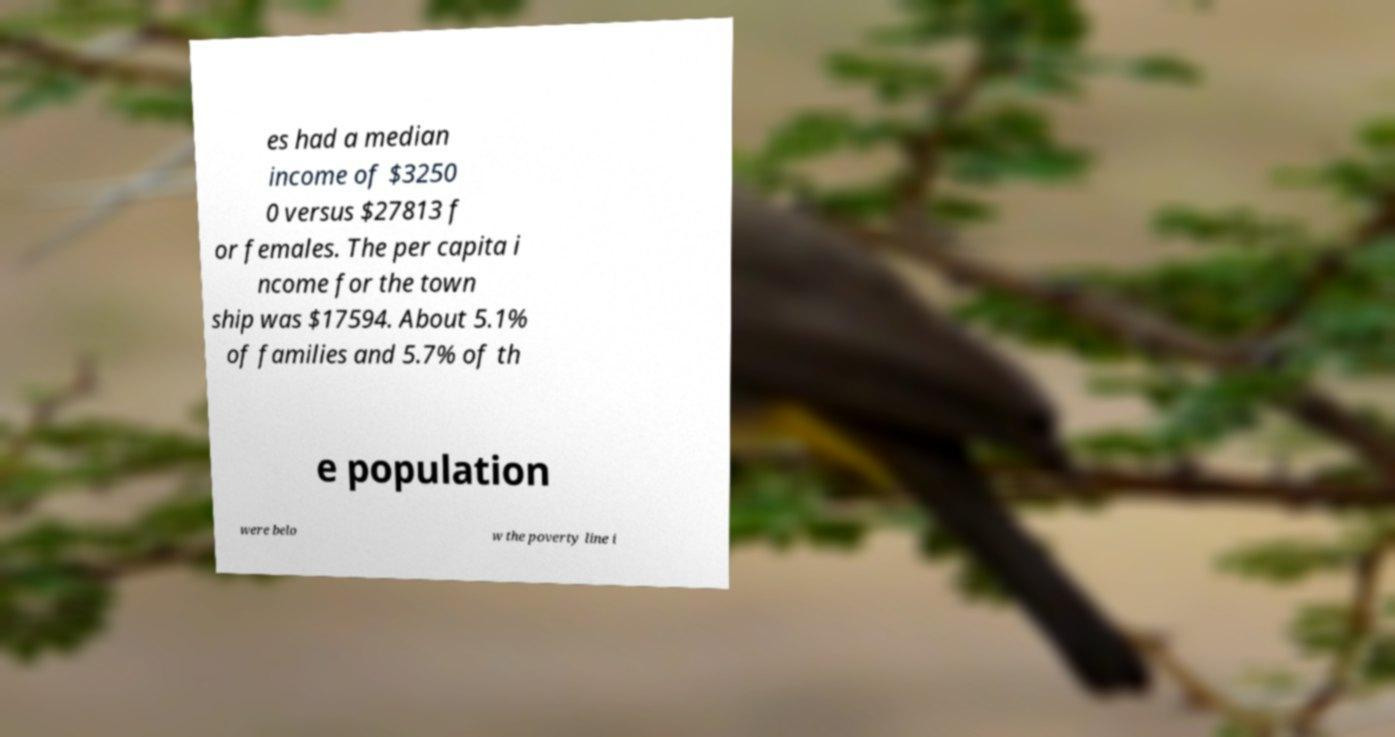Can you accurately transcribe the text from the provided image for me? es had a median income of $3250 0 versus $27813 f or females. The per capita i ncome for the town ship was $17594. About 5.1% of families and 5.7% of th e population were belo w the poverty line i 